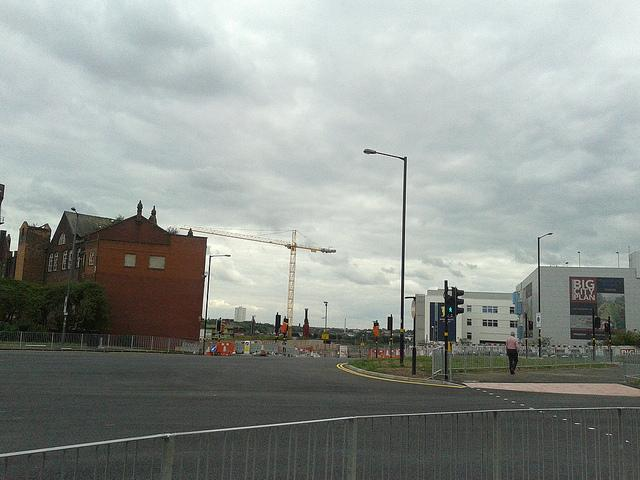What is the yellow structure in the background used for?

Choices:
A) lifting things
B) throwing things
C) climbing
D) holding things lifting things 